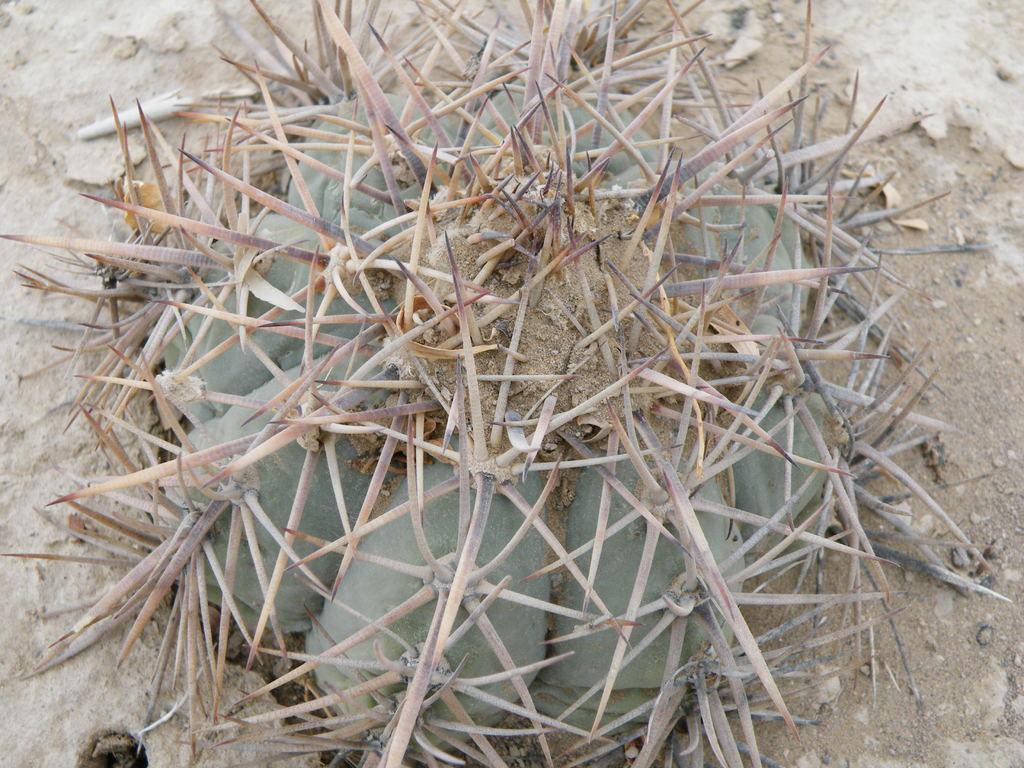In one or two sentences, can you explain what this image depicts? This is a plant, this is a sky. 